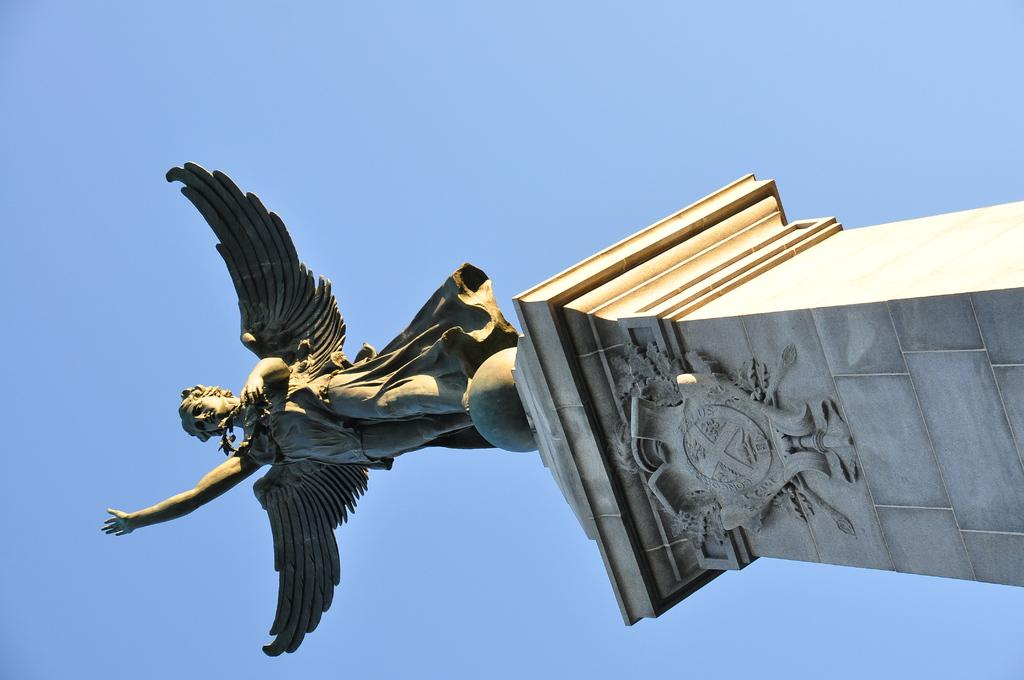What is the main subject of the image? There is a statue in the image. Where is the statue located? The statue is on a pillar. What can be seen in the background of the image? The sky is visible behind the statue. How many rings are visible on the statue's fingers in the image? There are no rings visible on the statue's fingers in the image, as the statue is not a person and does not have fingers. 